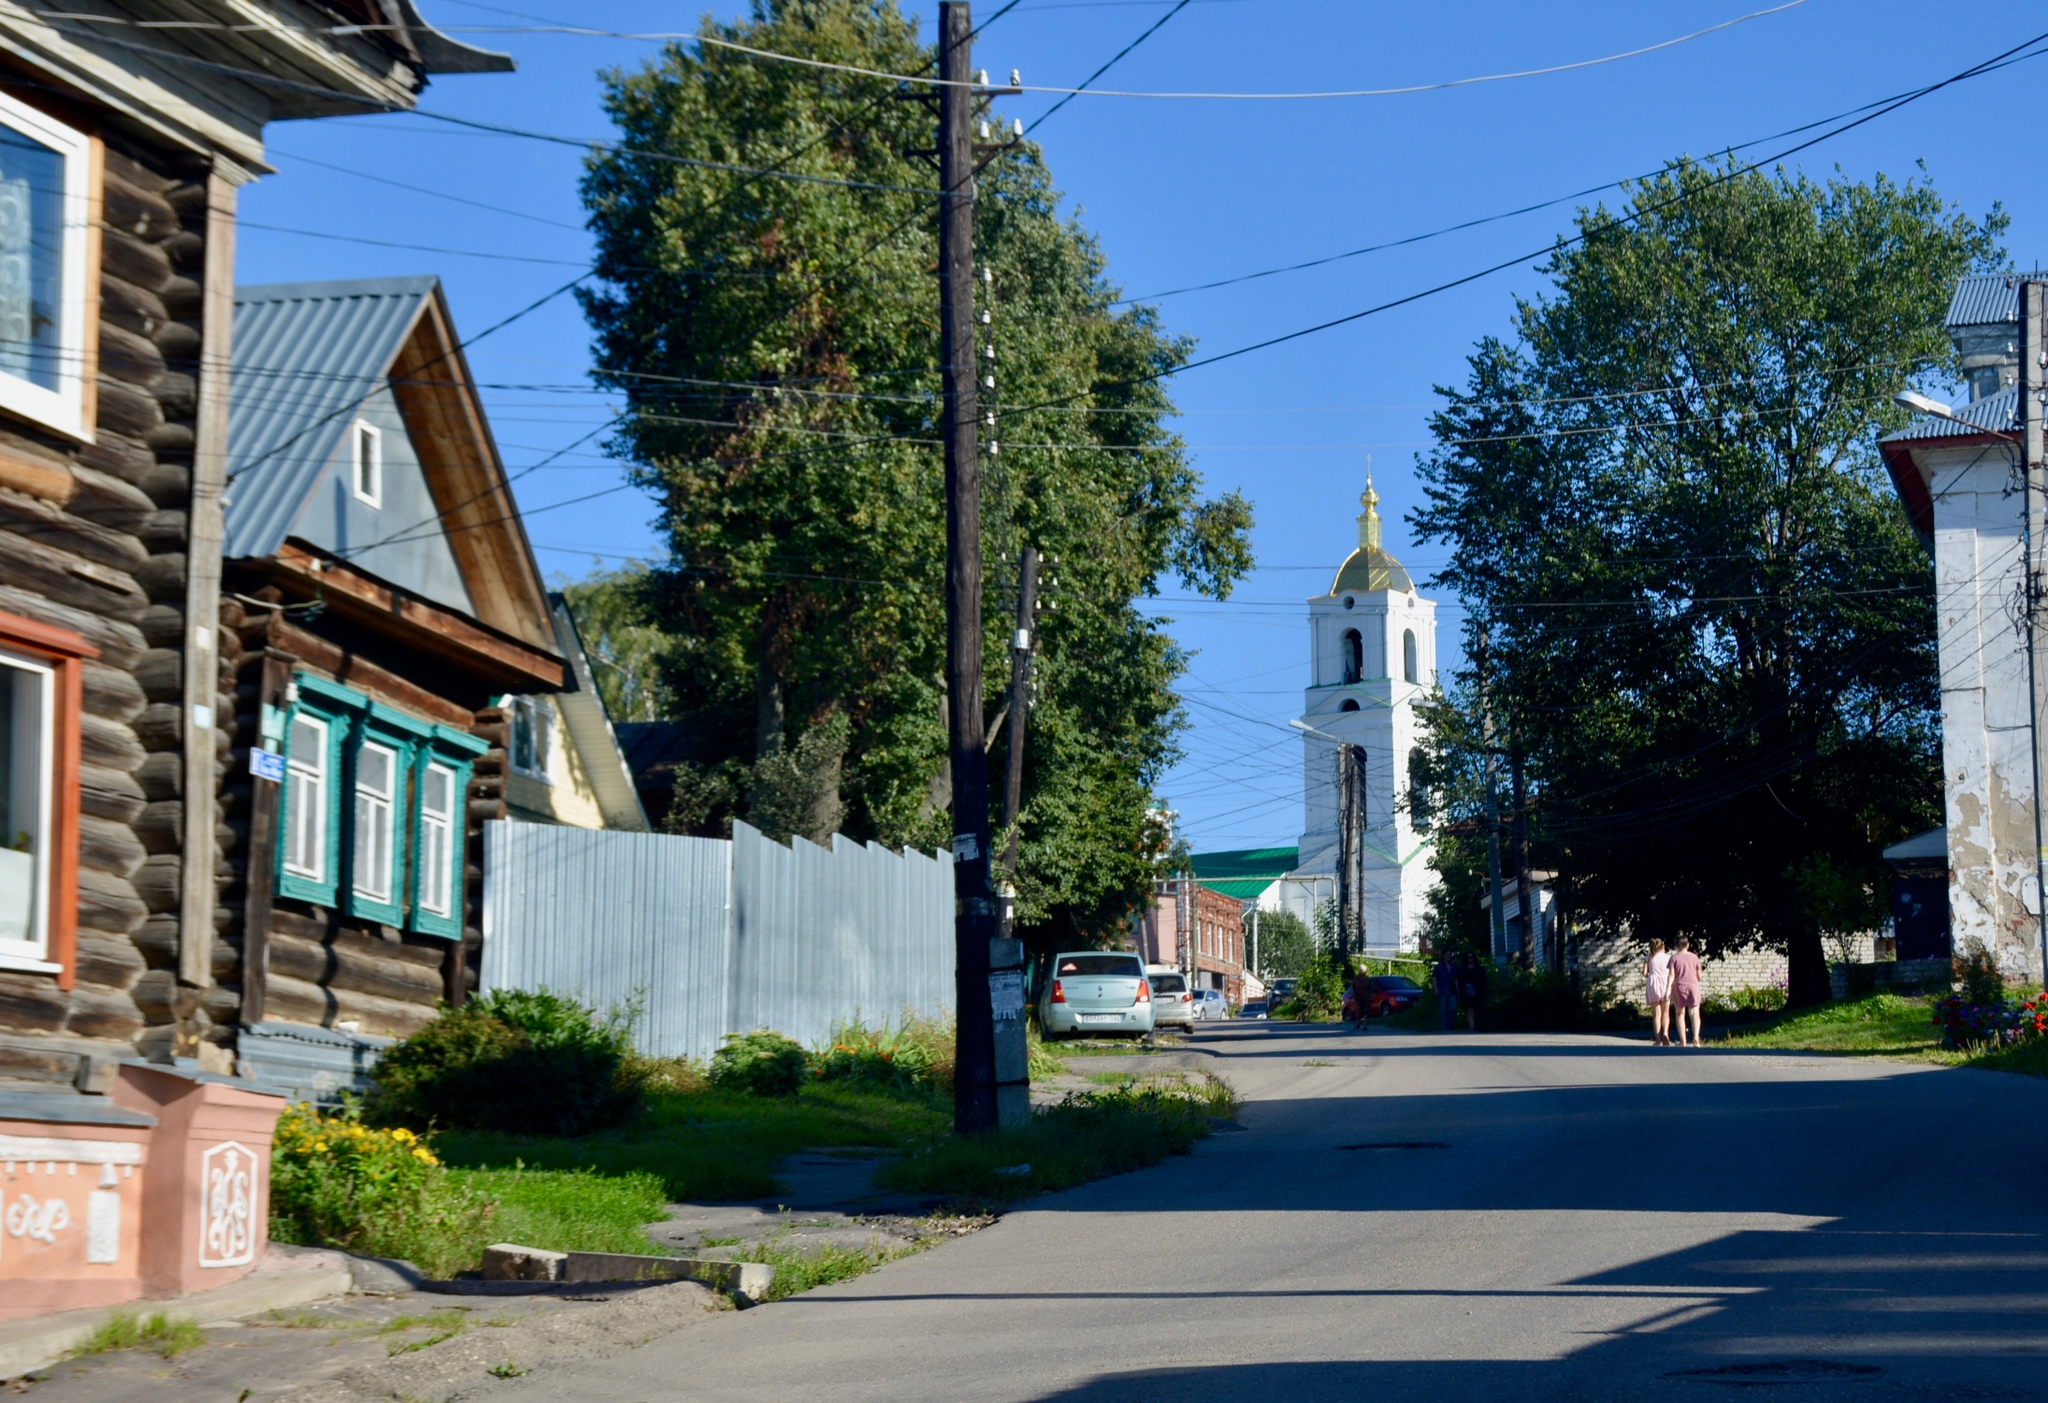Can you describe the architectural styles visible in this image? The image showcases a mixture of architectural styles that are indicative of a historical and culturally rich town. The dominant structures are wooden houses, characterized by their rustic, log-cabin appearance, complete with decorative window frames painted in bright colors, adding a quaint charm. The white church tower in the background exhibits a more classical style, with its elongated windows and prominent dome capped with a gold cross, likely reflecting the religious heritage of the area. 